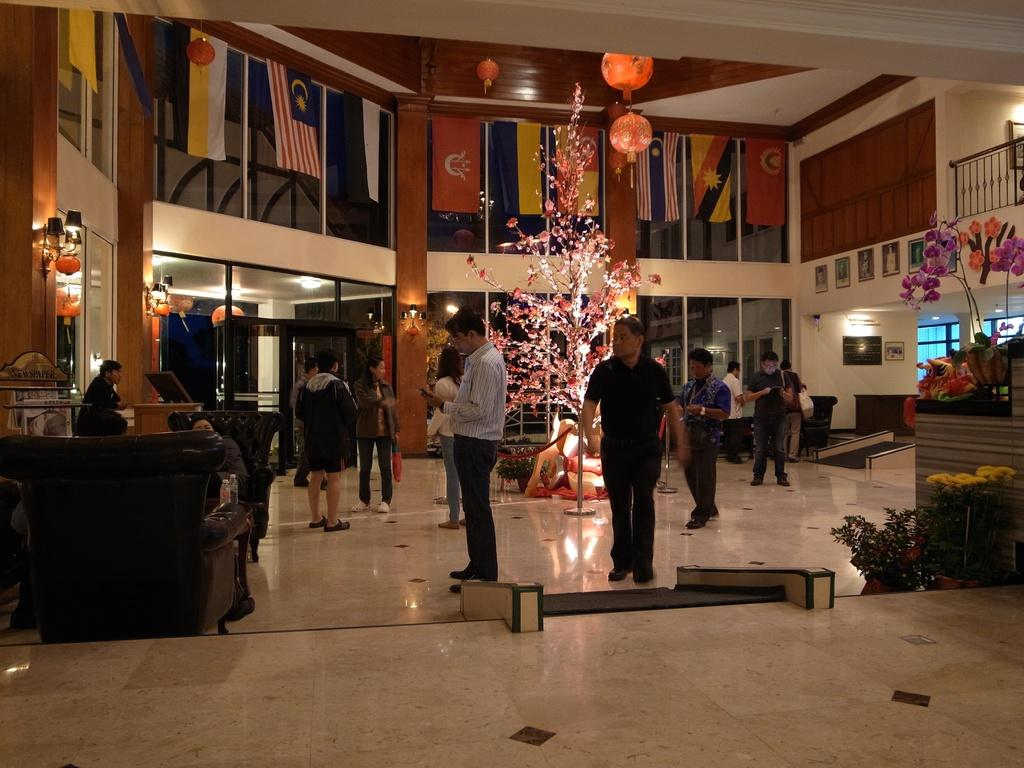How many people are in the image? There is a group of people standing in the image. What objects are present in the image that are related to decoration? Flower sticks, plants with flowers, paper lanterns, flags, and lights are present in the image. What type of furniture is visible in the image? Chairs are visible in the image. What is attached to the wall in the image? Frames are attached to the wall in the image. What shape is the fireman's hat in the image? There is no fireman or hat present in the image. What type of material is the brick wall made of in the image? There is no brick wall present in the image. 